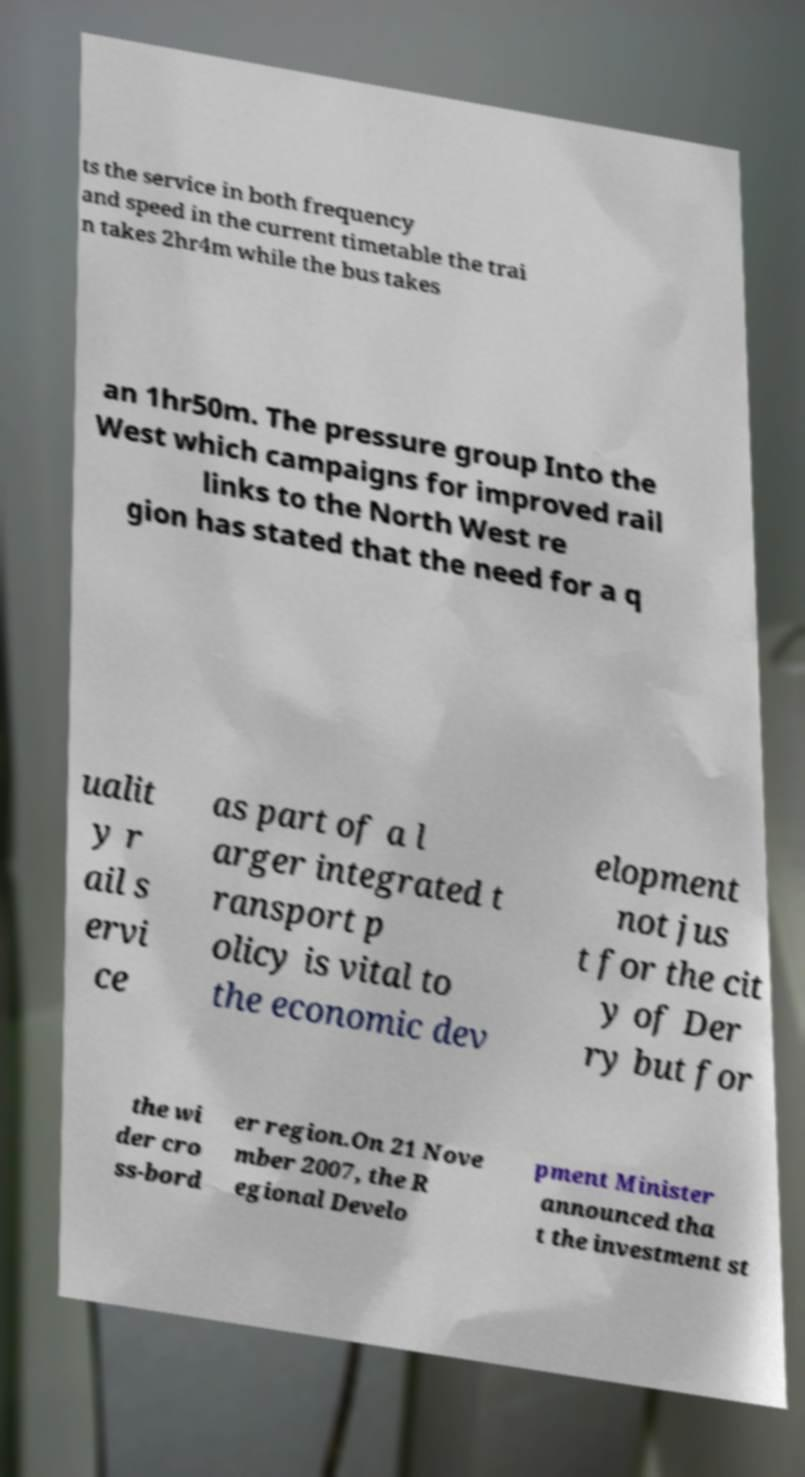Please read and relay the text visible in this image. What does it say? ts the service in both frequency and speed in the current timetable the trai n takes 2hr4m while the bus takes an 1hr50m. The pressure group Into the West which campaigns for improved rail links to the North West re gion has stated that the need for a q ualit y r ail s ervi ce as part of a l arger integrated t ransport p olicy is vital to the economic dev elopment not jus t for the cit y of Der ry but for the wi der cro ss-bord er region.On 21 Nove mber 2007, the R egional Develo pment Minister announced tha t the investment st 